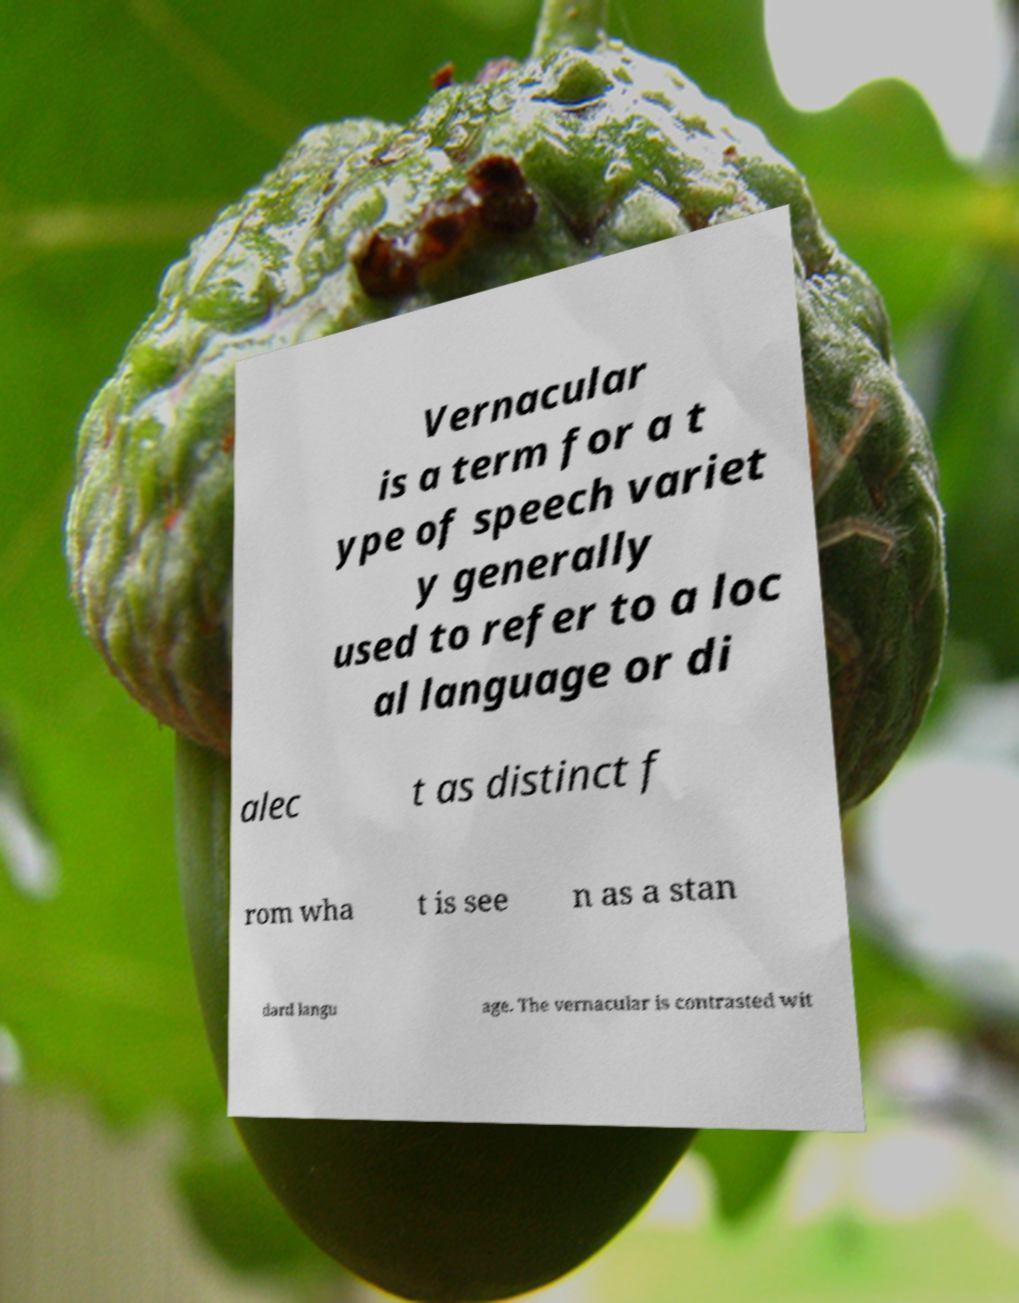What messages or text are displayed in this image? I need them in a readable, typed format. Vernacular is a term for a t ype of speech variet y generally used to refer to a loc al language or di alec t as distinct f rom wha t is see n as a stan dard langu age. The vernacular is contrasted wit 